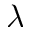Convert formula to latex. <formula><loc_0><loc_0><loc_500><loc_500>{ \lambda }</formula> 